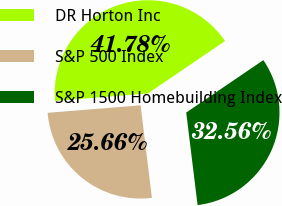Convert chart to OTSL. <chart><loc_0><loc_0><loc_500><loc_500><pie_chart><fcel>DR Horton Inc<fcel>S&P 500 Index<fcel>S&P 1500 Homebuilding Index<nl><fcel>41.78%<fcel>25.66%<fcel>32.56%<nl></chart> 